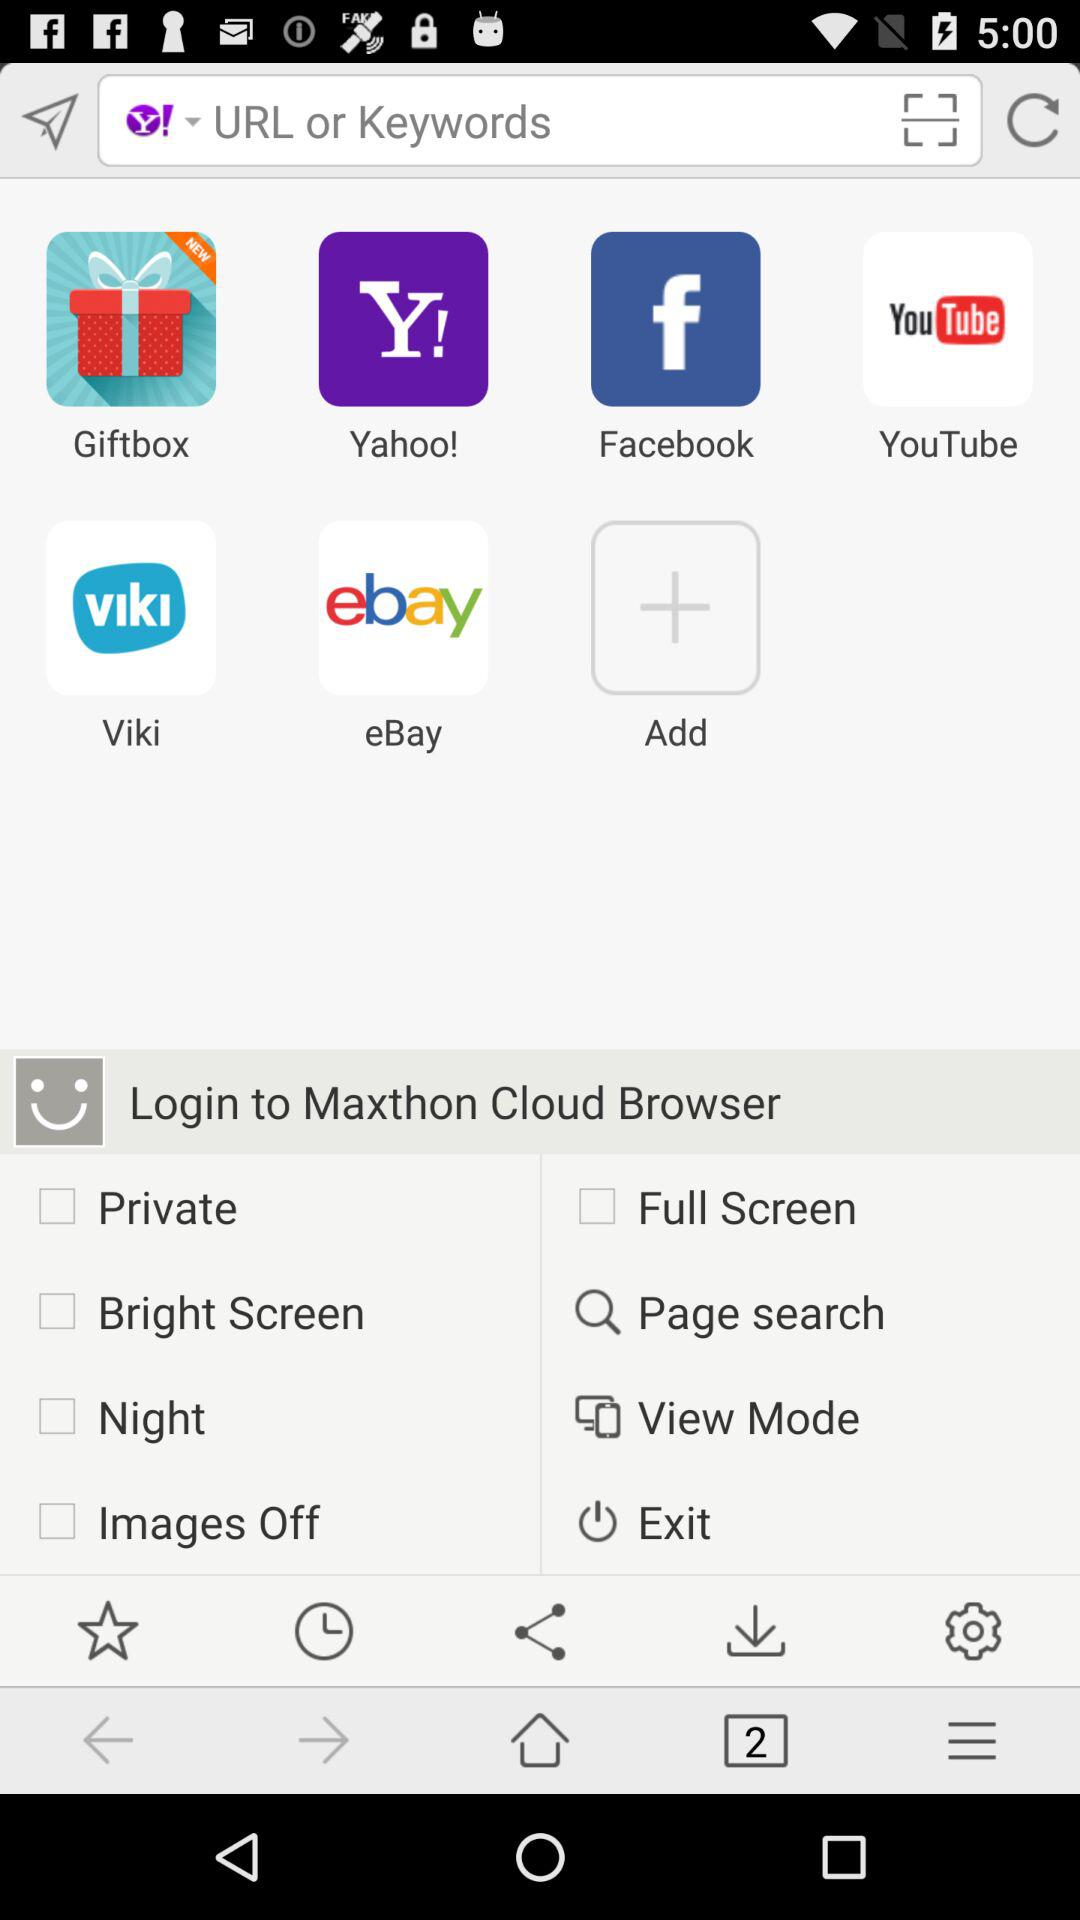What is the number of tabs? The number of tabs is 2. 